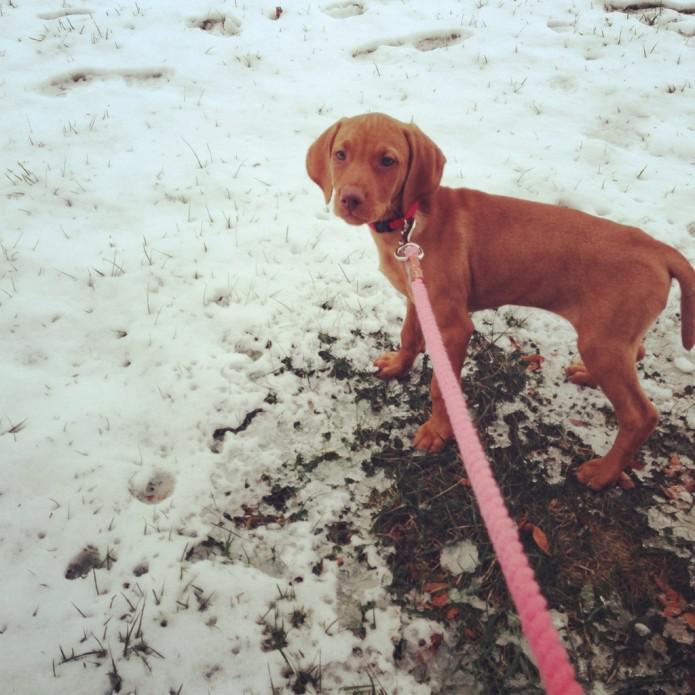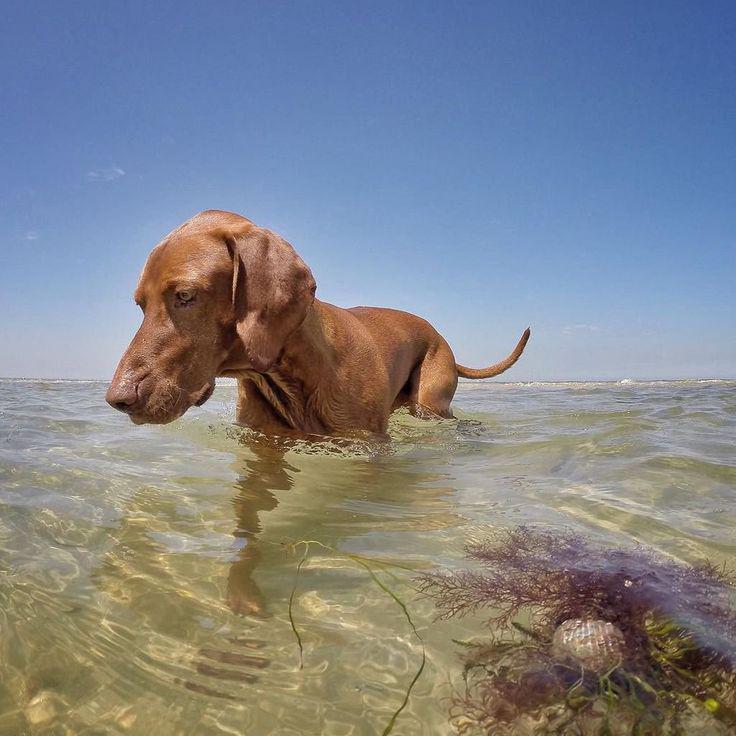The first image is the image on the left, the second image is the image on the right. Assess this claim about the two images: "There's at least one dog on a leash in one picture and the other picture of a dog is taken at the beach.". Correct or not? Answer yes or no. Yes. The first image is the image on the left, the second image is the image on the right. Evaluate the accuracy of this statement regarding the images: "A female is standing behind a dog with its head and body turned leftward in the right image.". Is it true? Answer yes or no. No. 